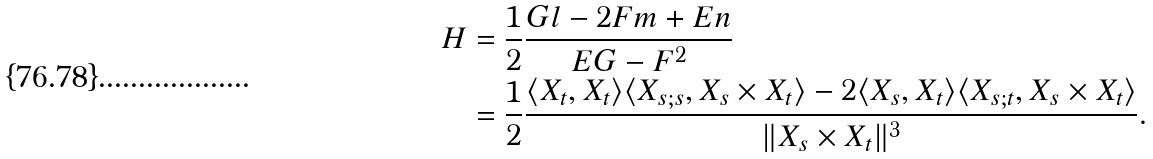<formula> <loc_0><loc_0><loc_500><loc_500>H & = \frac { 1 } { 2 } \frac { G l - 2 F m + E n } { E G - F ^ { 2 } } \\ & = \frac { 1 } { 2 } \frac { \langle X _ { t } , X _ { t } \rangle \langle X _ { s ; s } , X _ { s } \times X _ { t } \rangle - 2 \langle X _ { s } , X _ { t } \rangle \langle X _ { s ; t } , X _ { s } \times X _ { t } \rangle } { \| X _ { s } \times X _ { t } \| ^ { 3 } } .</formula> 